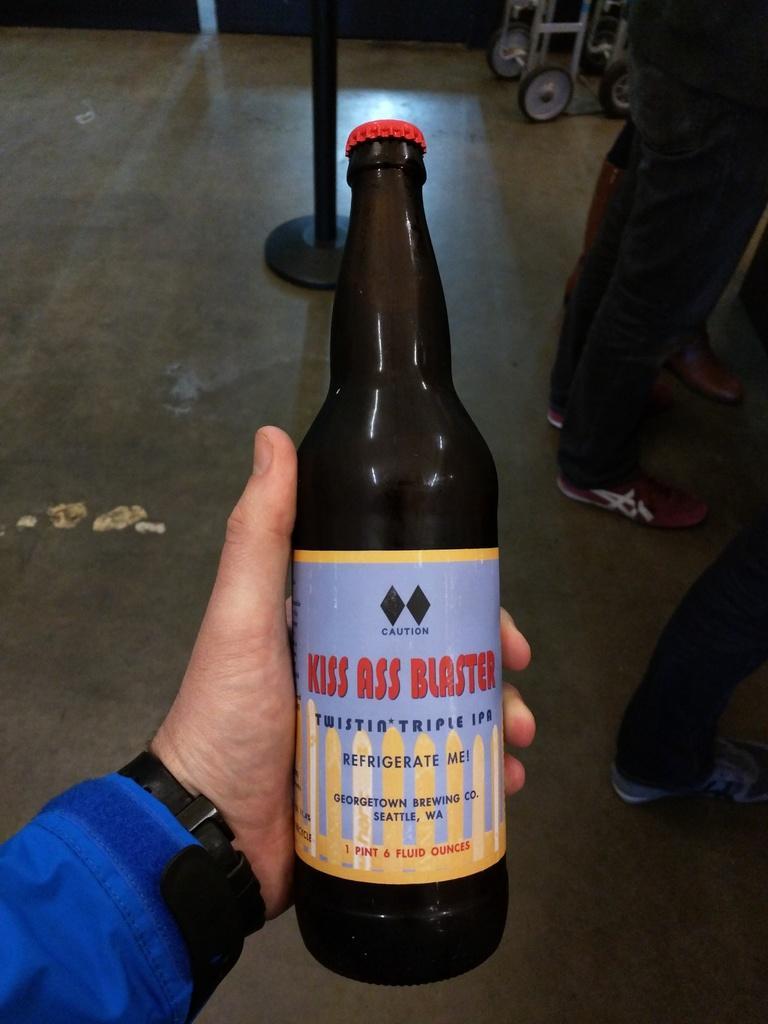In one or two sentences, can you explain what this image depicts? In this picture there is a bottle in the center of the image in a hand and there are people on the right side of the image, it seems to be a pole and wheels of a vehicle at the top side of the image. 